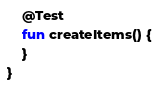Convert code to text. <code><loc_0><loc_0><loc_500><loc_500><_Kotlin_>
    @Test
    fun createItems() {
    }
}</code> 